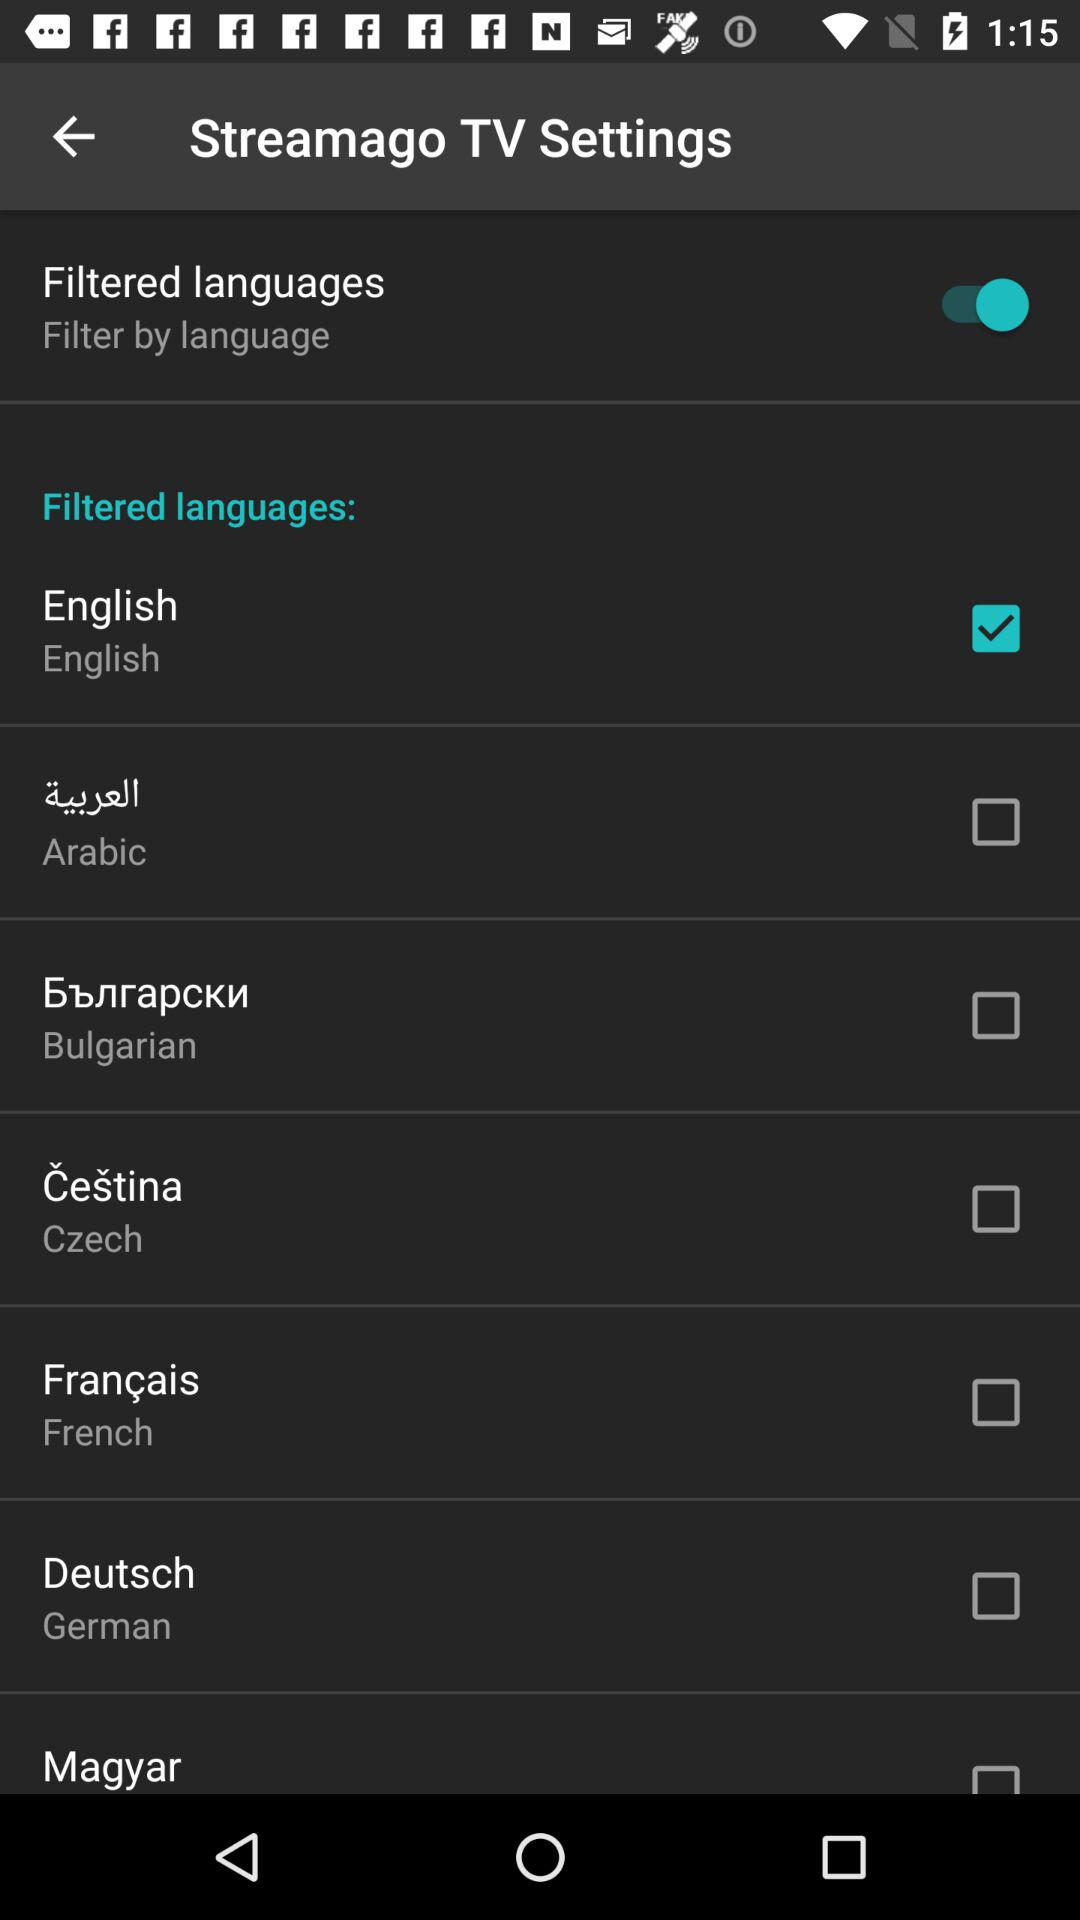What is the status of the German language? The status of the German language is off. 